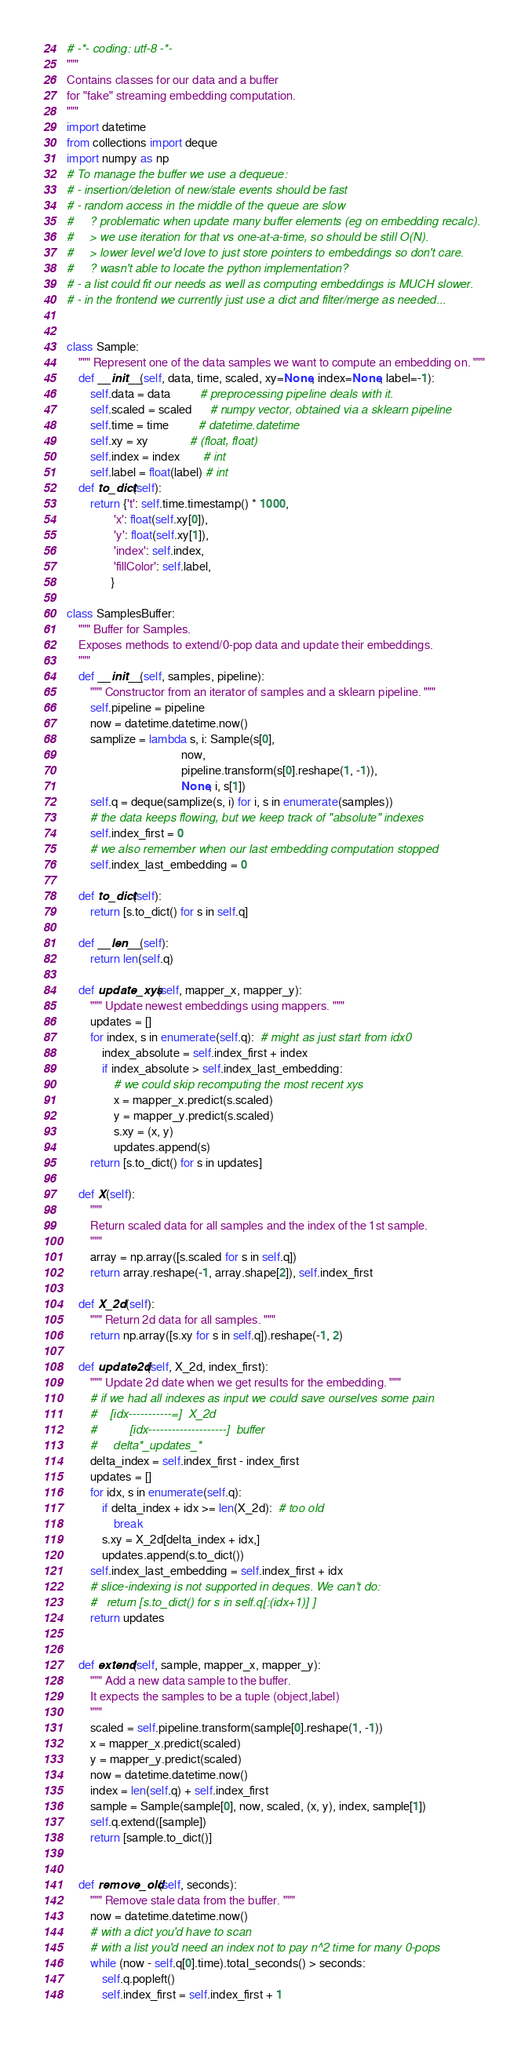Convert code to text. <code><loc_0><loc_0><loc_500><loc_500><_Python_># -*- coding: utf-8 -*-
"""
Contains classes for our data and a buffer
for "fake" streaming embedding computation.
"""
import datetime
from collections import deque
import numpy as np
# To manage the buffer we use a dequeue:
# - insertion/deletion of new/stale events should be fast
# - random access in the middle of the queue are slow
#     ? problematic when update many buffer elements (eg on embedding recalc).
#     > we use iteration for that vs one-at-a-time, so should be still O(N).
#     > lower level we'd love to just store pointers to embeddings so don't care.
#     ? wasn't able to locate the python implementation?
# - a list could fit our needs as well as computing embeddings is MUCH slower.
# - in the frontend we currently just use a dict and filter/merge as needed...


class Sample:
    """ Represent one of the data samples we want to compute an embedding on. """
    def __init__(self, data, time, scaled, xy=None, index=None, label=-1):
        self.data = data          # preprocessing pipeline deals with it.
        self.scaled = scaled      # numpy vector, obtained via a sklearn pipeline
        self.time = time          # datetime.datetime
        self.xy = xy              # (float, float)
        self.index = index        # int
        self.label = float(label) # int
    def to_dict(self):
        return {'t': self.time.timestamp() * 1000,
                'x': float(self.xy[0]),
                'y': float(self.xy[1]),
                'index': self.index,
                'fillColor': self.label,
               }

class SamplesBuffer:
    """ Buffer for Samples.
    Exposes methods to extend/0-pop data and update their embeddings.
    """
    def __init__(self, samples, pipeline):
        """ Constructor from an iterator of samples and a sklearn pipeline. """
        self.pipeline = pipeline
        now = datetime.datetime.now()
        samplize = lambda s, i: Sample(s[0],
                                       now,
                                       pipeline.transform(s[0].reshape(1, -1)),
                                       None, i, s[1])
        self.q = deque(samplize(s, i) for i, s in enumerate(samples))
        # the data keeps flowing, but we keep track of "absolute" indexes
        self.index_first = 0
        # we also remember when our last embedding computation stopped
        self.index_last_embedding = 0

    def to_dict(self):
        return [s.to_dict() for s in self.q]

    def __len__(self):
        return len(self.q)

    def update_xys(self, mapper_x, mapper_y):
        """ Update newest embeddings using mappers. """
        updates = []
        for index, s in enumerate(self.q):  # might as just start from idx0
            index_absolute = self.index_first + index
            if index_absolute > self.index_last_embedding:
                # we could skip recomputing the most recent xys
                x = mapper_x.predict(s.scaled)
                y = mapper_y.predict(s.scaled)
                s.xy = (x, y)
                updates.append(s)
        return [s.to_dict() for s in updates]

    def X(self):
        """
        Return scaled data for all samples and the index of the 1st sample.
        """
        array = np.array([s.scaled for s in self.q])
        return array.reshape(-1, array.shape[2]), self.index_first

    def X_2d(self):
        """ Return 2d data for all samples. """
        return np.array([s.xy for s in self.q]).reshape(-1, 2)

    def update2d(self, X_2d, index_first):
        """ Update 2d date when we get results for the embedding. """
        # if we had all indexes as input we could save ourselves some pain
        #    [idx-----------=]  X_2d
        #          [idx--------------------]  buffer
        #     delta*_updates_*
        delta_index = self.index_first - index_first
        updates = []
        for idx, s in enumerate(self.q):
            if delta_index + idx >= len(X_2d):  # too old
                break
            s.xy = X_2d[delta_index + idx,]
            updates.append(s.to_dict())
        self.index_last_embedding = self.index_first + idx
        # slice-indexing is not supported in deques. We can't do:
        #   return [s.to_dict() for s in self.q[:(idx+1)] ]
        return updates


    def extend(self, sample, mapper_x, mapper_y):
        """ Add a new data sample to the buffer.
        It expects the samples to be a tuple (object,label)
        """
        scaled = self.pipeline.transform(sample[0].reshape(1, -1))
        x = mapper_x.predict(scaled)
        y = mapper_y.predict(scaled)
        now = datetime.datetime.now()
        index = len(self.q) + self.index_first
        sample = Sample(sample[0], now, scaled, (x, y), index, sample[1])
        self.q.extend([sample])
        return [sample.to_dict()]


    def remove_old(self, seconds):
        """ Remove stale data from the buffer. """
        now = datetime.datetime.now()
        # with a dict you'd have to scan
        # with a list you'd need an index not to pay n^2 time for many 0-pops
        while (now - self.q[0].time).total_seconds() > seconds:
            self.q.popleft()
            self.index_first = self.index_first + 1
</code> 